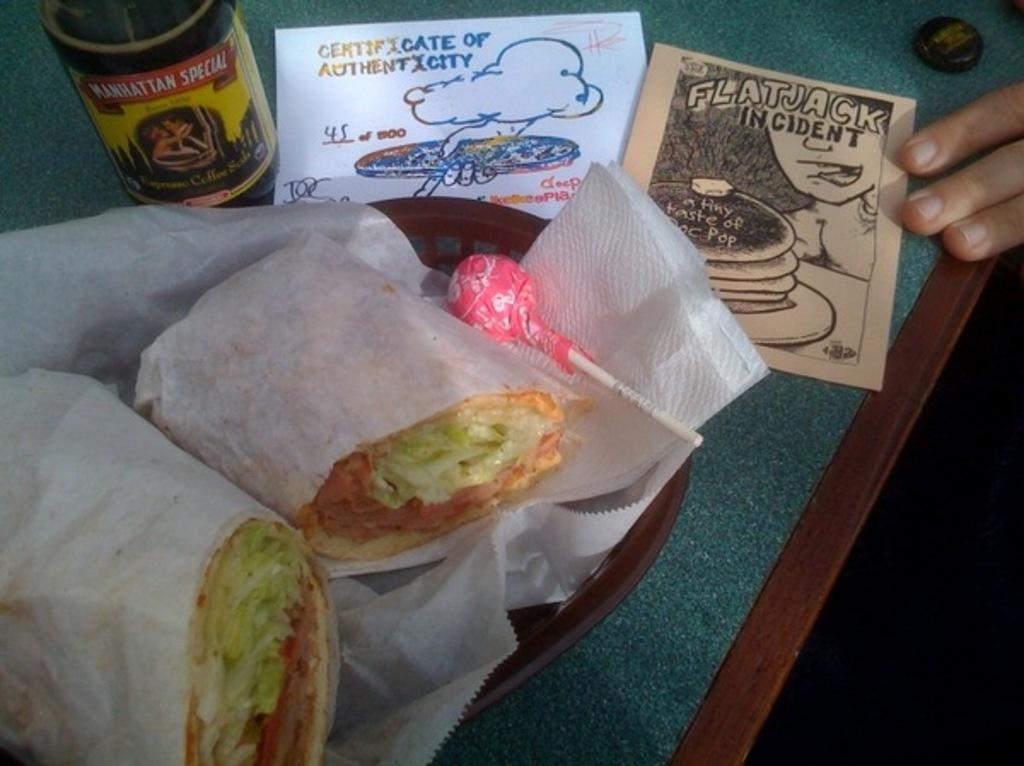What is the main piece of furniture in the image? There is a table in the image. What is placed on the table? There is a basket with food items on the table. What else can be seen in the image besides the table and food items? There are papers and a bottle in the image. Can you describe the person's fingers visible on the right side of the image? A person's fingers are visible on the right side of the image, but their identity or activity cannot be determined from the image. What scientific experiment is being conducted in the image? There is no scientific experiment visible in the image. Is there a volleyball game happening in the image? There is no volleyball game or any reference to sports in the image. 